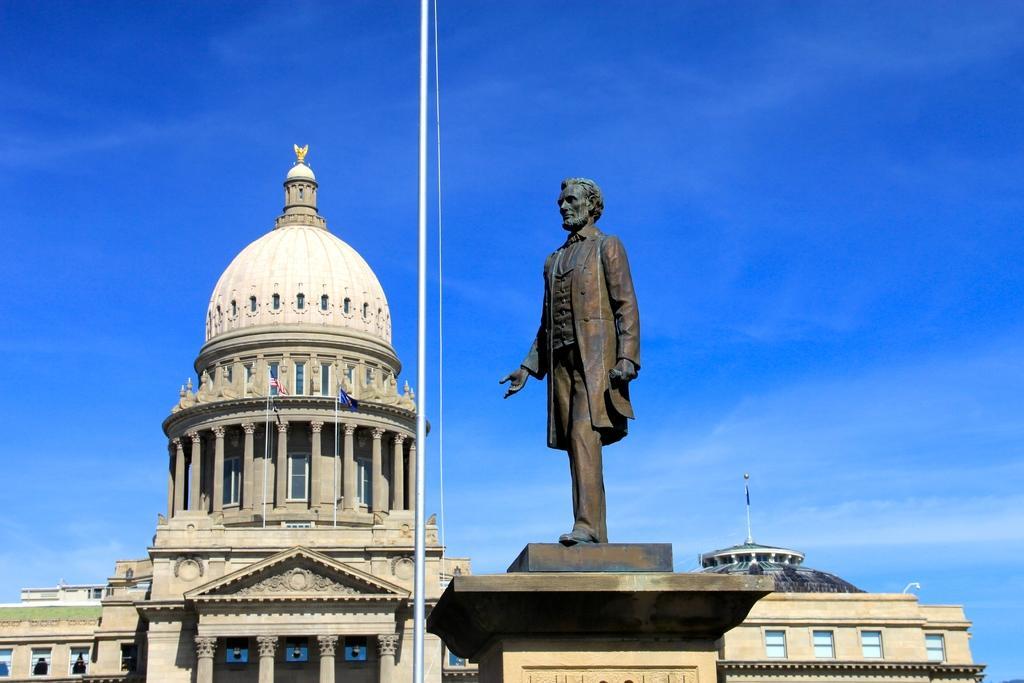Please provide a concise description of this image. As we can see in the image there is a building, statue and a sky. 